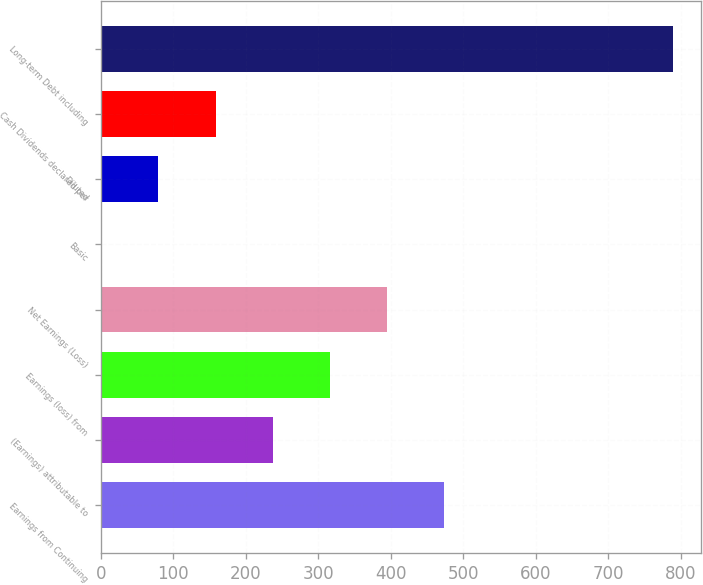Convert chart to OTSL. <chart><loc_0><loc_0><loc_500><loc_500><bar_chart><fcel>Earnings from Continuing<fcel>(Earnings) attributable to<fcel>Earnings (loss) from<fcel>Net Earnings (Loss)<fcel>Basic<fcel>Diluted<fcel>Cash Dividends declared per<fcel>Long-term Debt including<nl><fcel>473.72<fcel>237.23<fcel>316.06<fcel>394.89<fcel>0.74<fcel>79.57<fcel>158.4<fcel>789<nl></chart> 